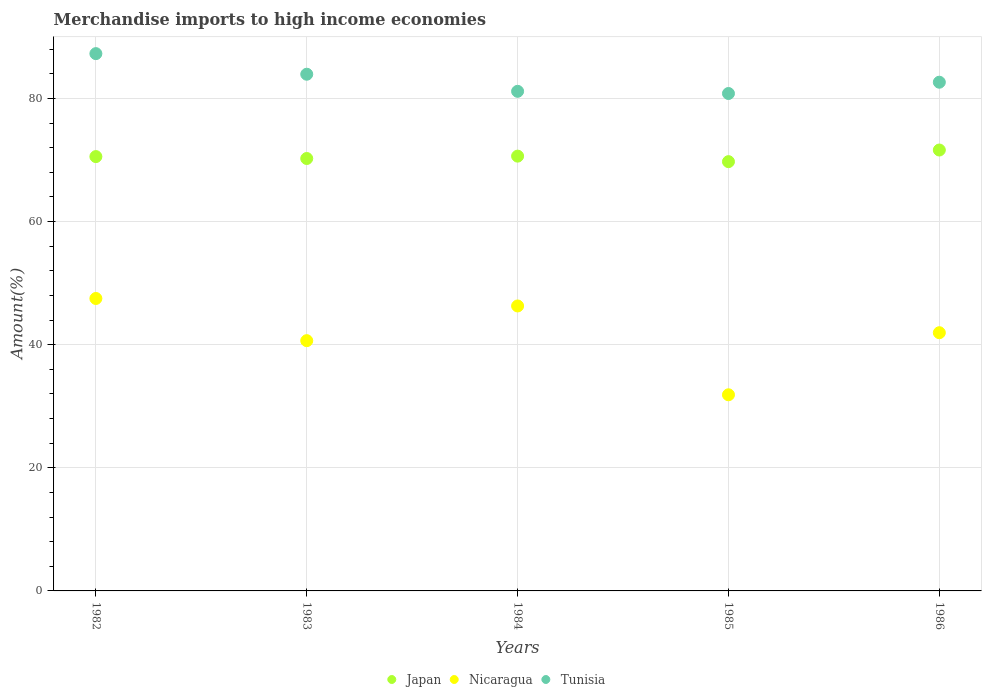What is the percentage of amount earned from merchandise imports in Tunisia in 1985?
Your answer should be compact. 80.81. Across all years, what is the maximum percentage of amount earned from merchandise imports in Nicaragua?
Ensure brevity in your answer.  47.51. Across all years, what is the minimum percentage of amount earned from merchandise imports in Tunisia?
Make the answer very short. 80.81. In which year was the percentage of amount earned from merchandise imports in Tunisia maximum?
Keep it short and to the point. 1982. In which year was the percentage of amount earned from merchandise imports in Japan minimum?
Make the answer very short. 1985. What is the total percentage of amount earned from merchandise imports in Nicaragua in the graph?
Give a very brief answer. 208.28. What is the difference between the percentage of amount earned from merchandise imports in Nicaragua in 1982 and that in 1984?
Make the answer very short. 1.22. What is the difference between the percentage of amount earned from merchandise imports in Japan in 1985 and the percentage of amount earned from merchandise imports in Nicaragua in 1982?
Ensure brevity in your answer.  22.23. What is the average percentage of amount earned from merchandise imports in Tunisia per year?
Offer a very short reply. 83.17. In the year 1986, what is the difference between the percentage of amount earned from merchandise imports in Tunisia and percentage of amount earned from merchandise imports in Japan?
Ensure brevity in your answer.  11.02. What is the ratio of the percentage of amount earned from merchandise imports in Tunisia in 1982 to that in 1985?
Give a very brief answer. 1.08. Is the percentage of amount earned from merchandise imports in Nicaragua in 1982 less than that in 1985?
Your answer should be compact. No. Is the difference between the percentage of amount earned from merchandise imports in Tunisia in 1984 and 1986 greater than the difference between the percentage of amount earned from merchandise imports in Japan in 1984 and 1986?
Provide a short and direct response. No. What is the difference between the highest and the second highest percentage of amount earned from merchandise imports in Japan?
Your response must be concise. 0.99. What is the difference between the highest and the lowest percentage of amount earned from merchandise imports in Tunisia?
Keep it short and to the point. 6.48. In how many years, is the percentage of amount earned from merchandise imports in Nicaragua greater than the average percentage of amount earned from merchandise imports in Nicaragua taken over all years?
Your answer should be very brief. 3. Is it the case that in every year, the sum of the percentage of amount earned from merchandise imports in Japan and percentage of amount earned from merchandise imports in Tunisia  is greater than the percentage of amount earned from merchandise imports in Nicaragua?
Give a very brief answer. Yes. Does the percentage of amount earned from merchandise imports in Japan monotonically increase over the years?
Your answer should be compact. No. Is the percentage of amount earned from merchandise imports in Nicaragua strictly greater than the percentage of amount earned from merchandise imports in Japan over the years?
Your answer should be very brief. No. Is the percentage of amount earned from merchandise imports in Tunisia strictly less than the percentage of amount earned from merchandise imports in Nicaragua over the years?
Offer a very short reply. No. What is the difference between two consecutive major ticks on the Y-axis?
Ensure brevity in your answer.  20. Does the graph contain any zero values?
Provide a short and direct response. No. Does the graph contain grids?
Give a very brief answer. Yes. Where does the legend appear in the graph?
Your response must be concise. Bottom center. How are the legend labels stacked?
Give a very brief answer. Horizontal. What is the title of the graph?
Your response must be concise. Merchandise imports to high income economies. What is the label or title of the X-axis?
Provide a short and direct response. Years. What is the label or title of the Y-axis?
Make the answer very short. Amount(%). What is the Amount(%) in Japan in 1982?
Ensure brevity in your answer.  70.56. What is the Amount(%) in Nicaragua in 1982?
Give a very brief answer. 47.51. What is the Amount(%) of Tunisia in 1982?
Offer a very short reply. 87.29. What is the Amount(%) of Japan in 1983?
Provide a succinct answer. 70.25. What is the Amount(%) of Nicaragua in 1983?
Offer a very short reply. 40.66. What is the Amount(%) of Tunisia in 1983?
Your answer should be compact. 83.95. What is the Amount(%) in Japan in 1984?
Give a very brief answer. 70.64. What is the Amount(%) of Nicaragua in 1984?
Make the answer very short. 46.3. What is the Amount(%) of Tunisia in 1984?
Keep it short and to the point. 81.17. What is the Amount(%) of Japan in 1985?
Your answer should be compact. 69.74. What is the Amount(%) of Nicaragua in 1985?
Keep it short and to the point. 31.87. What is the Amount(%) of Tunisia in 1985?
Offer a very short reply. 80.81. What is the Amount(%) in Japan in 1986?
Offer a terse response. 71.63. What is the Amount(%) of Nicaragua in 1986?
Ensure brevity in your answer.  41.95. What is the Amount(%) in Tunisia in 1986?
Give a very brief answer. 82.65. Across all years, what is the maximum Amount(%) of Japan?
Your response must be concise. 71.63. Across all years, what is the maximum Amount(%) of Nicaragua?
Provide a succinct answer. 47.51. Across all years, what is the maximum Amount(%) of Tunisia?
Give a very brief answer. 87.29. Across all years, what is the minimum Amount(%) of Japan?
Give a very brief answer. 69.74. Across all years, what is the minimum Amount(%) of Nicaragua?
Your response must be concise. 31.87. Across all years, what is the minimum Amount(%) of Tunisia?
Offer a terse response. 80.81. What is the total Amount(%) in Japan in the graph?
Your answer should be compact. 352.83. What is the total Amount(%) of Nicaragua in the graph?
Offer a very short reply. 208.28. What is the total Amount(%) of Tunisia in the graph?
Offer a very short reply. 415.87. What is the difference between the Amount(%) in Japan in 1982 and that in 1983?
Provide a succinct answer. 0.31. What is the difference between the Amount(%) of Nicaragua in 1982 and that in 1983?
Give a very brief answer. 6.85. What is the difference between the Amount(%) in Tunisia in 1982 and that in 1983?
Your response must be concise. 3.35. What is the difference between the Amount(%) in Japan in 1982 and that in 1984?
Provide a succinct answer. -0.07. What is the difference between the Amount(%) of Nicaragua in 1982 and that in 1984?
Your answer should be compact. 1.22. What is the difference between the Amount(%) in Tunisia in 1982 and that in 1984?
Provide a succinct answer. 6.12. What is the difference between the Amount(%) in Japan in 1982 and that in 1985?
Make the answer very short. 0.82. What is the difference between the Amount(%) of Nicaragua in 1982 and that in 1985?
Ensure brevity in your answer.  15.65. What is the difference between the Amount(%) of Tunisia in 1982 and that in 1985?
Make the answer very short. 6.48. What is the difference between the Amount(%) of Japan in 1982 and that in 1986?
Make the answer very short. -1.07. What is the difference between the Amount(%) in Nicaragua in 1982 and that in 1986?
Make the answer very short. 5.56. What is the difference between the Amount(%) of Tunisia in 1982 and that in 1986?
Ensure brevity in your answer.  4.64. What is the difference between the Amount(%) in Japan in 1983 and that in 1984?
Your answer should be compact. -0.39. What is the difference between the Amount(%) of Nicaragua in 1983 and that in 1984?
Offer a very short reply. -5.64. What is the difference between the Amount(%) in Tunisia in 1983 and that in 1984?
Your answer should be compact. 2.78. What is the difference between the Amount(%) in Japan in 1983 and that in 1985?
Make the answer very short. 0.51. What is the difference between the Amount(%) in Nicaragua in 1983 and that in 1985?
Your response must be concise. 8.79. What is the difference between the Amount(%) in Tunisia in 1983 and that in 1985?
Provide a succinct answer. 3.13. What is the difference between the Amount(%) in Japan in 1983 and that in 1986?
Your answer should be very brief. -1.38. What is the difference between the Amount(%) in Nicaragua in 1983 and that in 1986?
Your answer should be compact. -1.29. What is the difference between the Amount(%) of Tunisia in 1983 and that in 1986?
Your answer should be very brief. 1.3. What is the difference between the Amount(%) of Japan in 1984 and that in 1985?
Your response must be concise. 0.9. What is the difference between the Amount(%) in Nicaragua in 1984 and that in 1985?
Your answer should be very brief. 14.43. What is the difference between the Amount(%) of Tunisia in 1984 and that in 1985?
Offer a terse response. 0.35. What is the difference between the Amount(%) in Japan in 1984 and that in 1986?
Your answer should be compact. -0.99. What is the difference between the Amount(%) in Nicaragua in 1984 and that in 1986?
Offer a terse response. 4.35. What is the difference between the Amount(%) in Tunisia in 1984 and that in 1986?
Offer a very short reply. -1.48. What is the difference between the Amount(%) in Japan in 1985 and that in 1986?
Keep it short and to the point. -1.89. What is the difference between the Amount(%) in Nicaragua in 1985 and that in 1986?
Provide a succinct answer. -10.09. What is the difference between the Amount(%) of Tunisia in 1985 and that in 1986?
Your answer should be very brief. -1.83. What is the difference between the Amount(%) in Japan in 1982 and the Amount(%) in Nicaragua in 1983?
Provide a short and direct response. 29.91. What is the difference between the Amount(%) of Japan in 1982 and the Amount(%) of Tunisia in 1983?
Provide a succinct answer. -13.38. What is the difference between the Amount(%) in Nicaragua in 1982 and the Amount(%) in Tunisia in 1983?
Give a very brief answer. -36.43. What is the difference between the Amount(%) in Japan in 1982 and the Amount(%) in Nicaragua in 1984?
Keep it short and to the point. 24.27. What is the difference between the Amount(%) in Japan in 1982 and the Amount(%) in Tunisia in 1984?
Keep it short and to the point. -10.61. What is the difference between the Amount(%) of Nicaragua in 1982 and the Amount(%) of Tunisia in 1984?
Make the answer very short. -33.66. What is the difference between the Amount(%) in Japan in 1982 and the Amount(%) in Nicaragua in 1985?
Offer a very short reply. 38.7. What is the difference between the Amount(%) in Japan in 1982 and the Amount(%) in Tunisia in 1985?
Make the answer very short. -10.25. What is the difference between the Amount(%) in Nicaragua in 1982 and the Amount(%) in Tunisia in 1985?
Your answer should be very brief. -33.3. What is the difference between the Amount(%) of Japan in 1982 and the Amount(%) of Nicaragua in 1986?
Make the answer very short. 28.61. What is the difference between the Amount(%) of Japan in 1982 and the Amount(%) of Tunisia in 1986?
Make the answer very short. -12.08. What is the difference between the Amount(%) in Nicaragua in 1982 and the Amount(%) in Tunisia in 1986?
Give a very brief answer. -35.14. What is the difference between the Amount(%) in Japan in 1983 and the Amount(%) in Nicaragua in 1984?
Offer a very short reply. 23.96. What is the difference between the Amount(%) in Japan in 1983 and the Amount(%) in Tunisia in 1984?
Your answer should be very brief. -10.92. What is the difference between the Amount(%) of Nicaragua in 1983 and the Amount(%) of Tunisia in 1984?
Offer a terse response. -40.51. What is the difference between the Amount(%) in Japan in 1983 and the Amount(%) in Nicaragua in 1985?
Your response must be concise. 38.39. What is the difference between the Amount(%) in Japan in 1983 and the Amount(%) in Tunisia in 1985?
Ensure brevity in your answer.  -10.56. What is the difference between the Amount(%) in Nicaragua in 1983 and the Amount(%) in Tunisia in 1985?
Keep it short and to the point. -40.16. What is the difference between the Amount(%) in Japan in 1983 and the Amount(%) in Nicaragua in 1986?
Make the answer very short. 28.3. What is the difference between the Amount(%) in Japan in 1983 and the Amount(%) in Tunisia in 1986?
Offer a terse response. -12.39. What is the difference between the Amount(%) in Nicaragua in 1983 and the Amount(%) in Tunisia in 1986?
Ensure brevity in your answer.  -41.99. What is the difference between the Amount(%) in Japan in 1984 and the Amount(%) in Nicaragua in 1985?
Provide a short and direct response. 38.77. What is the difference between the Amount(%) in Japan in 1984 and the Amount(%) in Tunisia in 1985?
Give a very brief answer. -10.18. What is the difference between the Amount(%) of Nicaragua in 1984 and the Amount(%) of Tunisia in 1985?
Offer a terse response. -34.52. What is the difference between the Amount(%) in Japan in 1984 and the Amount(%) in Nicaragua in 1986?
Give a very brief answer. 28.69. What is the difference between the Amount(%) in Japan in 1984 and the Amount(%) in Tunisia in 1986?
Make the answer very short. -12.01. What is the difference between the Amount(%) in Nicaragua in 1984 and the Amount(%) in Tunisia in 1986?
Your answer should be very brief. -36.35. What is the difference between the Amount(%) of Japan in 1985 and the Amount(%) of Nicaragua in 1986?
Your answer should be very brief. 27.79. What is the difference between the Amount(%) of Japan in 1985 and the Amount(%) of Tunisia in 1986?
Provide a short and direct response. -12.91. What is the difference between the Amount(%) of Nicaragua in 1985 and the Amount(%) of Tunisia in 1986?
Your answer should be compact. -50.78. What is the average Amount(%) of Japan per year?
Your answer should be compact. 70.57. What is the average Amount(%) in Nicaragua per year?
Provide a succinct answer. 41.66. What is the average Amount(%) of Tunisia per year?
Ensure brevity in your answer.  83.17. In the year 1982, what is the difference between the Amount(%) in Japan and Amount(%) in Nicaragua?
Ensure brevity in your answer.  23.05. In the year 1982, what is the difference between the Amount(%) of Japan and Amount(%) of Tunisia?
Provide a short and direct response. -16.73. In the year 1982, what is the difference between the Amount(%) in Nicaragua and Amount(%) in Tunisia?
Ensure brevity in your answer.  -39.78. In the year 1983, what is the difference between the Amount(%) in Japan and Amount(%) in Nicaragua?
Make the answer very short. 29.6. In the year 1983, what is the difference between the Amount(%) of Japan and Amount(%) of Tunisia?
Your answer should be compact. -13.69. In the year 1983, what is the difference between the Amount(%) in Nicaragua and Amount(%) in Tunisia?
Provide a succinct answer. -43.29. In the year 1984, what is the difference between the Amount(%) in Japan and Amount(%) in Nicaragua?
Offer a very short reply. 24.34. In the year 1984, what is the difference between the Amount(%) of Japan and Amount(%) of Tunisia?
Your answer should be very brief. -10.53. In the year 1984, what is the difference between the Amount(%) in Nicaragua and Amount(%) in Tunisia?
Your response must be concise. -34.87. In the year 1985, what is the difference between the Amount(%) of Japan and Amount(%) of Nicaragua?
Give a very brief answer. 37.88. In the year 1985, what is the difference between the Amount(%) in Japan and Amount(%) in Tunisia?
Make the answer very short. -11.07. In the year 1985, what is the difference between the Amount(%) of Nicaragua and Amount(%) of Tunisia?
Your answer should be compact. -48.95. In the year 1986, what is the difference between the Amount(%) of Japan and Amount(%) of Nicaragua?
Give a very brief answer. 29.68. In the year 1986, what is the difference between the Amount(%) in Japan and Amount(%) in Tunisia?
Your answer should be compact. -11.02. In the year 1986, what is the difference between the Amount(%) in Nicaragua and Amount(%) in Tunisia?
Your answer should be compact. -40.7. What is the ratio of the Amount(%) in Japan in 1982 to that in 1983?
Your answer should be compact. 1. What is the ratio of the Amount(%) in Nicaragua in 1982 to that in 1983?
Give a very brief answer. 1.17. What is the ratio of the Amount(%) in Tunisia in 1982 to that in 1983?
Your response must be concise. 1.04. What is the ratio of the Amount(%) in Japan in 1982 to that in 1984?
Offer a very short reply. 1. What is the ratio of the Amount(%) in Nicaragua in 1982 to that in 1984?
Offer a very short reply. 1.03. What is the ratio of the Amount(%) in Tunisia in 1982 to that in 1984?
Your response must be concise. 1.08. What is the ratio of the Amount(%) in Japan in 1982 to that in 1985?
Your answer should be compact. 1.01. What is the ratio of the Amount(%) of Nicaragua in 1982 to that in 1985?
Provide a succinct answer. 1.49. What is the ratio of the Amount(%) of Tunisia in 1982 to that in 1985?
Give a very brief answer. 1.08. What is the ratio of the Amount(%) of Japan in 1982 to that in 1986?
Make the answer very short. 0.99. What is the ratio of the Amount(%) of Nicaragua in 1982 to that in 1986?
Offer a very short reply. 1.13. What is the ratio of the Amount(%) of Tunisia in 1982 to that in 1986?
Keep it short and to the point. 1.06. What is the ratio of the Amount(%) of Japan in 1983 to that in 1984?
Keep it short and to the point. 0.99. What is the ratio of the Amount(%) of Nicaragua in 1983 to that in 1984?
Keep it short and to the point. 0.88. What is the ratio of the Amount(%) in Tunisia in 1983 to that in 1984?
Make the answer very short. 1.03. What is the ratio of the Amount(%) of Japan in 1983 to that in 1985?
Give a very brief answer. 1.01. What is the ratio of the Amount(%) in Nicaragua in 1983 to that in 1985?
Offer a very short reply. 1.28. What is the ratio of the Amount(%) in Tunisia in 1983 to that in 1985?
Your response must be concise. 1.04. What is the ratio of the Amount(%) of Japan in 1983 to that in 1986?
Offer a terse response. 0.98. What is the ratio of the Amount(%) of Nicaragua in 1983 to that in 1986?
Provide a succinct answer. 0.97. What is the ratio of the Amount(%) of Tunisia in 1983 to that in 1986?
Your answer should be very brief. 1.02. What is the ratio of the Amount(%) of Japan in 1984 to that in 1985?
Keep it short and to the point. 1.01. What is the ratio of the Amount(%) of Nicaragua in 1984 to that in 1985?
Provide a short and direct response. 1.45. What is the ratio of the Amount(%) of Japan in 1984 to that in 1986?
Your answer should be very brief. 0.99. What is the ratio of the Amount(%) in Nicaragua in 1984 to that in 1986?
Ensure brevity in your answer.  1.1. What is the ratio of the Amount(%) in Tunisia in 1984 to that in 1986?
Offer a very short reply. 0.98. What is the ratio of the Amount(%) in Japan in 1985 to that in 1986?
Ensure brevity in your answer.  0.97. What is the ratio of the Amount(%) of Nicaragua in 1985 to that in 1986?
Make the answer very short. 0.76. What is the ratio of the Amount(%) in Tunisia in 1985 to that in 1986?
Give a very brief answer. 0.98. What is the difference between the highest and the second highest Amount(%) of Nicaragua?
Keep it short and to the point. 1.22. What is the difference between the highest and the second highest Amount(%) of Tunisia?
Your answer should be compact. 3.35. What is the difference between the highest and the lowest Amount(%) in Japan?
Your answer should be very brief. 1.89. What is the difference between the highest and the lowest Amount(%) of Nicaragua?
Provide a succinct answer. 15.65. What is the difference between the highest and the lowest Amount(%) of Tunisia?
Your answer should be compact. 6.48. 